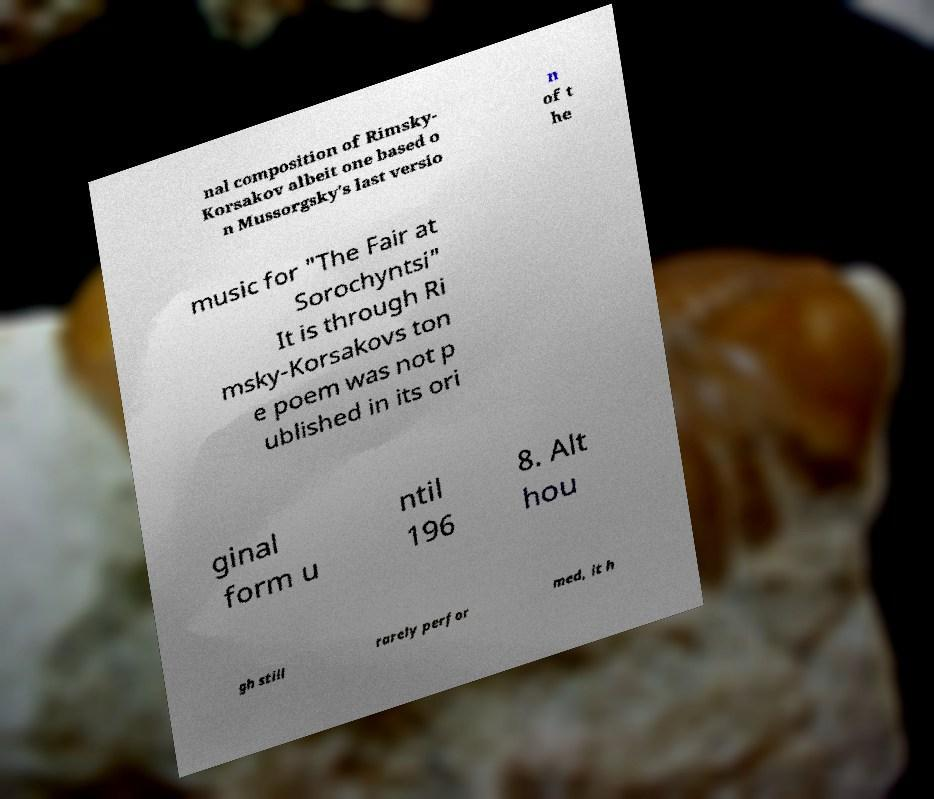There's text embedded in this image that I need extracted. Can you transcribe it verbatim? nal composition of Rimsky- Korsakov albeit one based o n Mussorgsky's last versio n of t he music for "The Fair at Sorochyntsi" It is through Ri msky-Korsakovs ton e poem was not p ublished in its ori ginal form u ntil 196 8. Alt hou gh still rarely perfor med, it h 